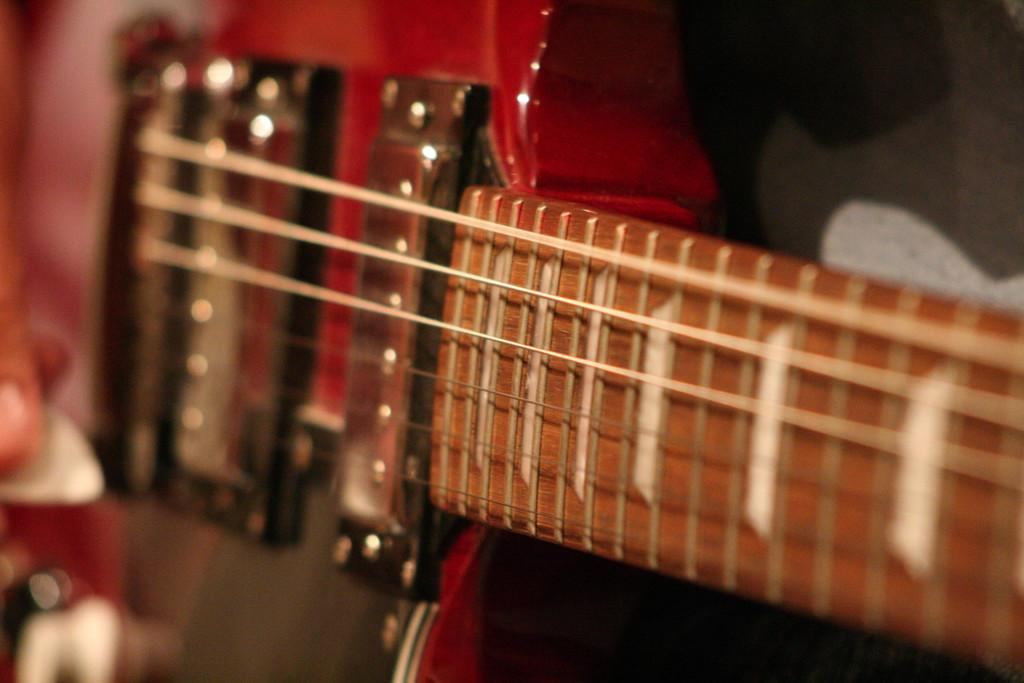What musical instrument is present in the image? There is a guitar in the image. What type of hall is depicted in the image? There is no hall present in the image; it only features a guitar. How does the guitar show care for the environment in the image? The image does not depict any actions or features related to caring for the environment; it simply shows a guitar. 